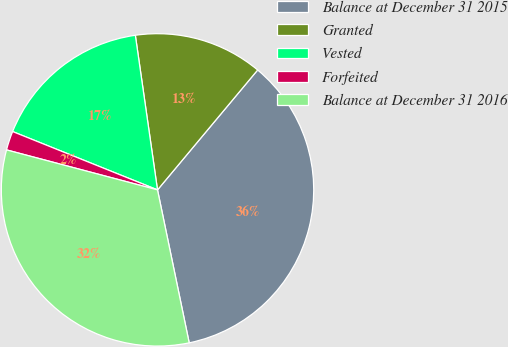<chart> <loc_0><loc_0><loc_500><loc_500><pie_chart><fcel>Balance at December 31 2015<fcel>Granted<fcel>Vested<fcel>Forfeited<fcel>Balance at December 31 2016<nl><fcel>35.67%<fcel>13.34%<fcel>16.64%<fcel>1.97%<fcel>32.37%<nl></chart> 